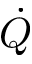Convert formula to latex. <formula><loc_0><loc_0><loc_500><loc_500>\dot { Q }</formula> 